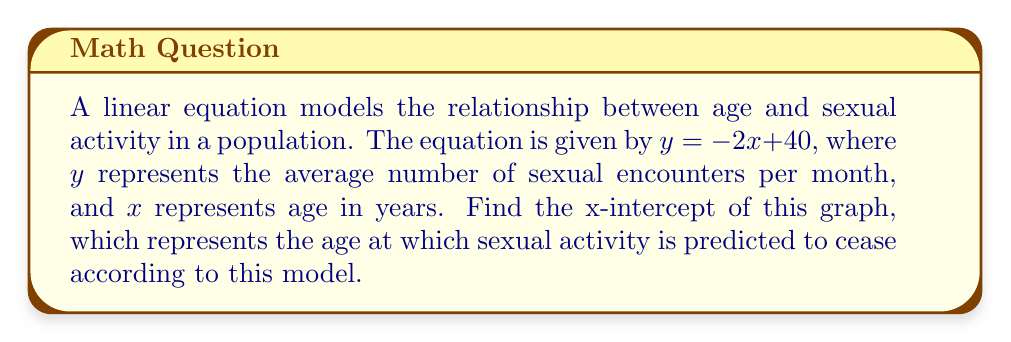What is the answer to this math problem? To find the x-intercept, we need to solve the equation when $y = 0$:

1) Start with the given equation:
   $y = -2x + 40$

2) Set $y = 0$:
   $0 = -2x + 40$

3) Subtract 40 from both sides:
   $-40 = -2x$

4) Divide both sides by -2:
   $20 = x$

The x-intercept occurs when $x = 20$. This means that according to this linear model, sexual activity is predicted to cease at age 20.

Note: This is a simplified model and does not accurately represent real-world situations. As a sexual health educator, it's important to emphasize that sexual activity varies greatly among individuals and age groups, and doesn't necessarily follow a linear pattern or cease at a specific age.
Answer: $x = 20$ 